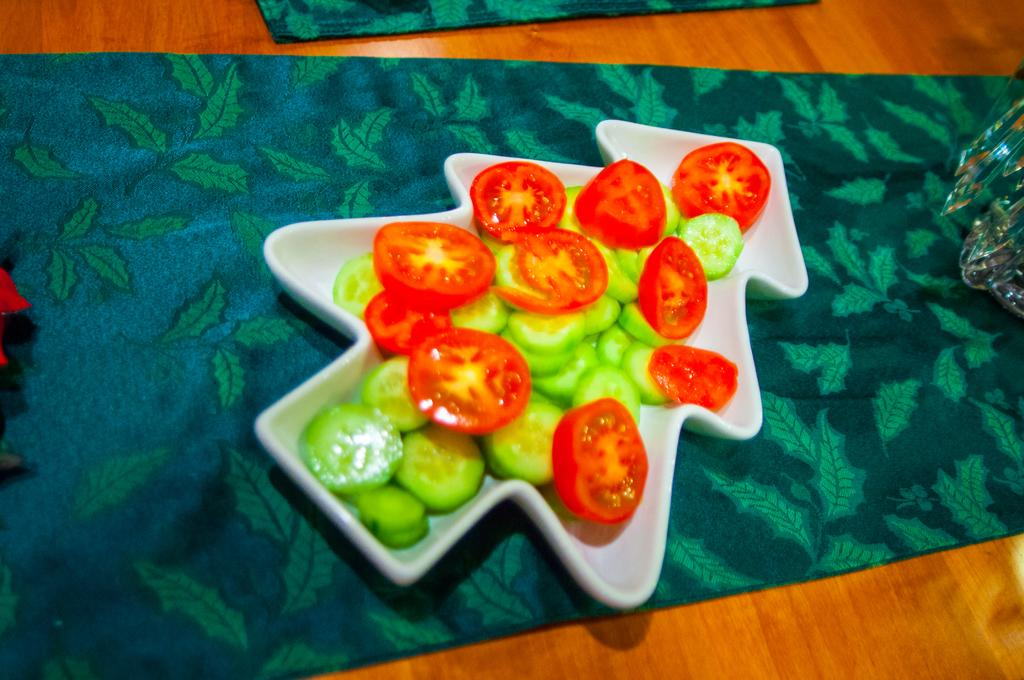What type of food is visible in the image? There are slices of tomato and cucumber in the image. How are the tomato and cucumber slices arranged in the image? The tomato and cucumber slices are in a plate. Where is the plate with the tomato and cucumber slices located? The plate is placed on a table. Can you describe the unspecified object beside the plate? Unfortunately, the facts provided do not give any details about the object beside the plate. How many men are working on the floor in the image? There are no men or work-related activities depicted in the image; it only shows tomato and cucumber slices in a plate on a table. 